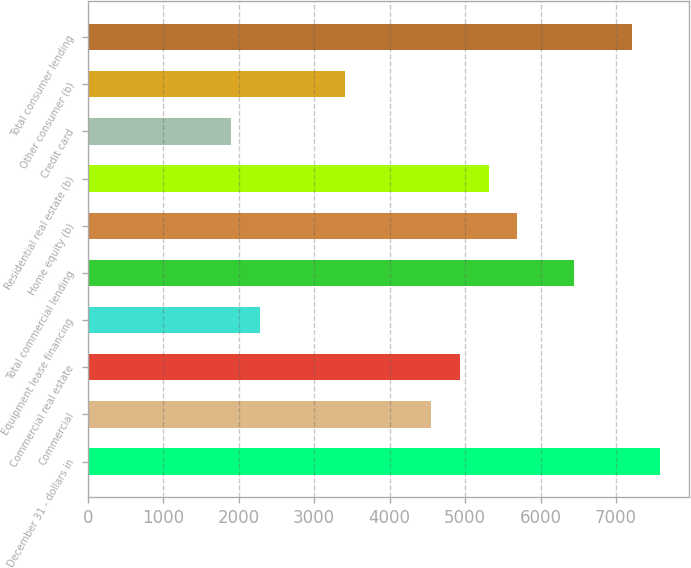Convert chart. <chart><loc_0><loc_0><loc_500><loc_500><bar_chart><fcel>December 31 - dollars in<fcel>Commercial<fcel>Commercial real estate<fcel>Equipment lease financing<fcel>Total commercial lending<fcel>Home equity (b)<fcel>Residential real estate (b)<fcel>Credit card<fcel>Other consumer (b)<fcel>Total consumer lending<nl><fcel>7587.03<fcel>4552.63<fcel>4931.93<fcel>2276.83<fcel>6449.13<fcel>5690.53<fcel>5311.23<fcel>1897.53<fcel>3414.73<fcel>7207.73<nl></chart> 